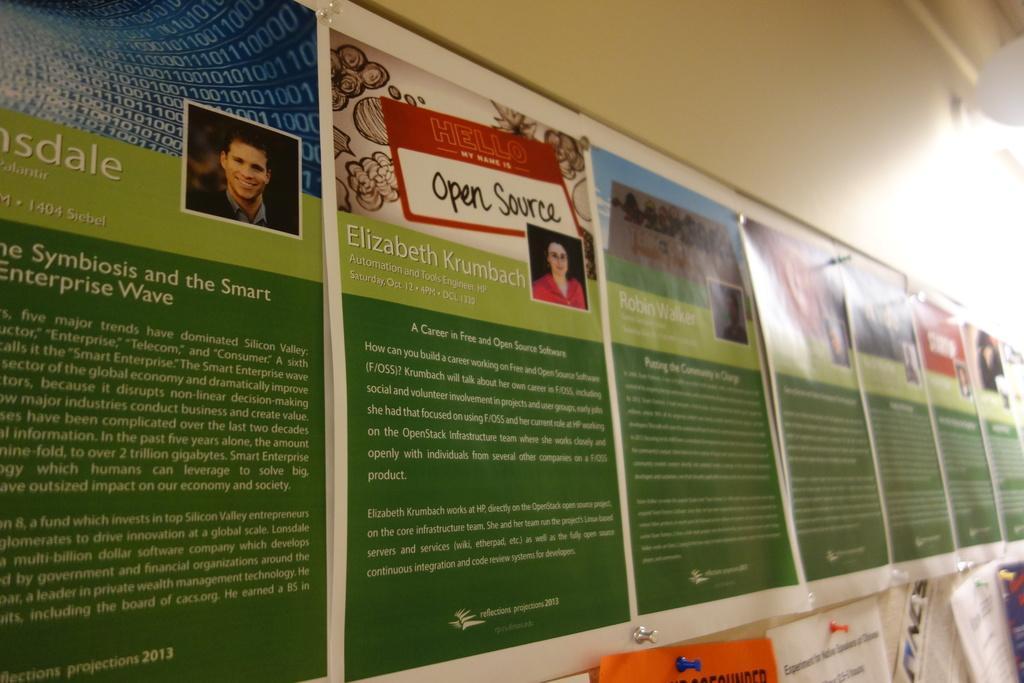In one or two sentences, can you explain what this image depicts? In the foreground of the picture there is a notice board, to the notice board there are posters printed. At the top there are light and wall. 